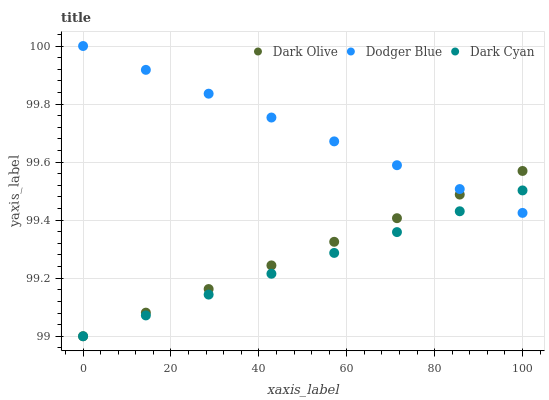Does Dark Cyan have the minimum area under the curve?
Answer yes or no. Yes. Does Dodger Blue have the maximum area under the curve?
Answer yes or no. Yes. Does Dark Olive have the minimum area under the curve?
Answer yes or no. No. Does Dark Olive have the maximum area under the curve?
Answer yes or no. No. Is Dark Cyan the smoothest?
Answer yes or no. Yes. Is Dodger Blue the roughest?
Answer yes or no. Yes. Is Dark Olive the smoothest?
Answer yes or no. No. Is Dark Olive the roughest?
Answer yes or no. No. Does Dark Cyan have the lowest value?
Answer yes or no. Yes. Does Dodger Blue have the lowest value?
Answer yes or no. No. Does Dodger Blue have the highest value?
Answer yes or no. Yes. Does Dark Olive have the highest value?
Answer yes or no. No. Does Dark Cyan intersect Dark Olive?
Answer yes or no. Yes. Is Dark Cyan less than Dark Olive?
Answer yes or no. No. Is Dark Cyan greater than Dark Olive?
Answer yes or no. No. 